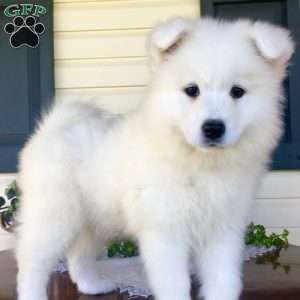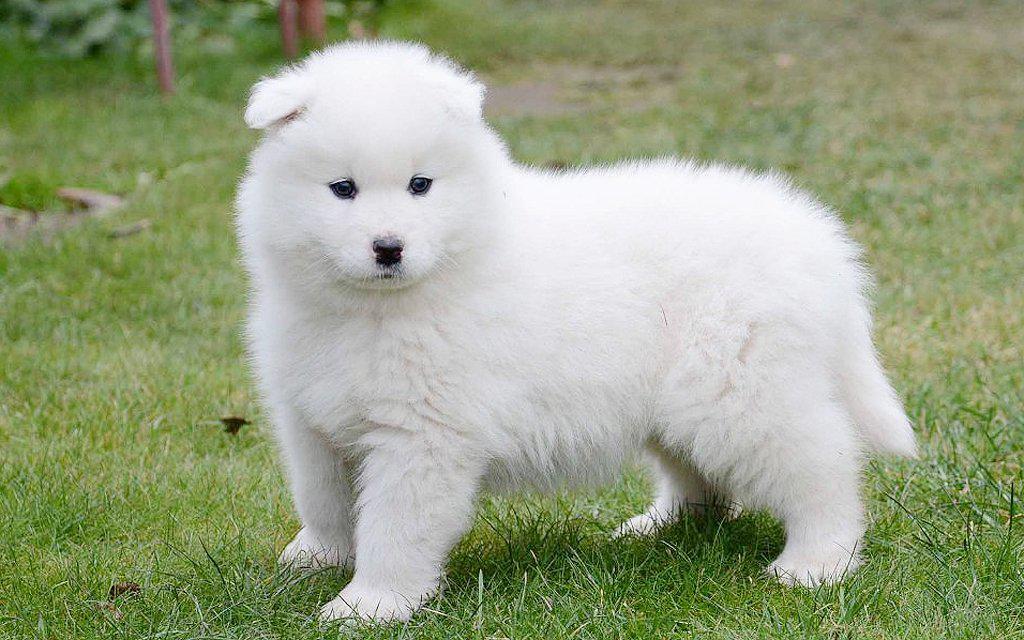The first image is the image on the left, the second image is the image on the right. Given the left and right images, does the statement "There are eight dog legs visible" hold true? Answer yes or no. Yes. 